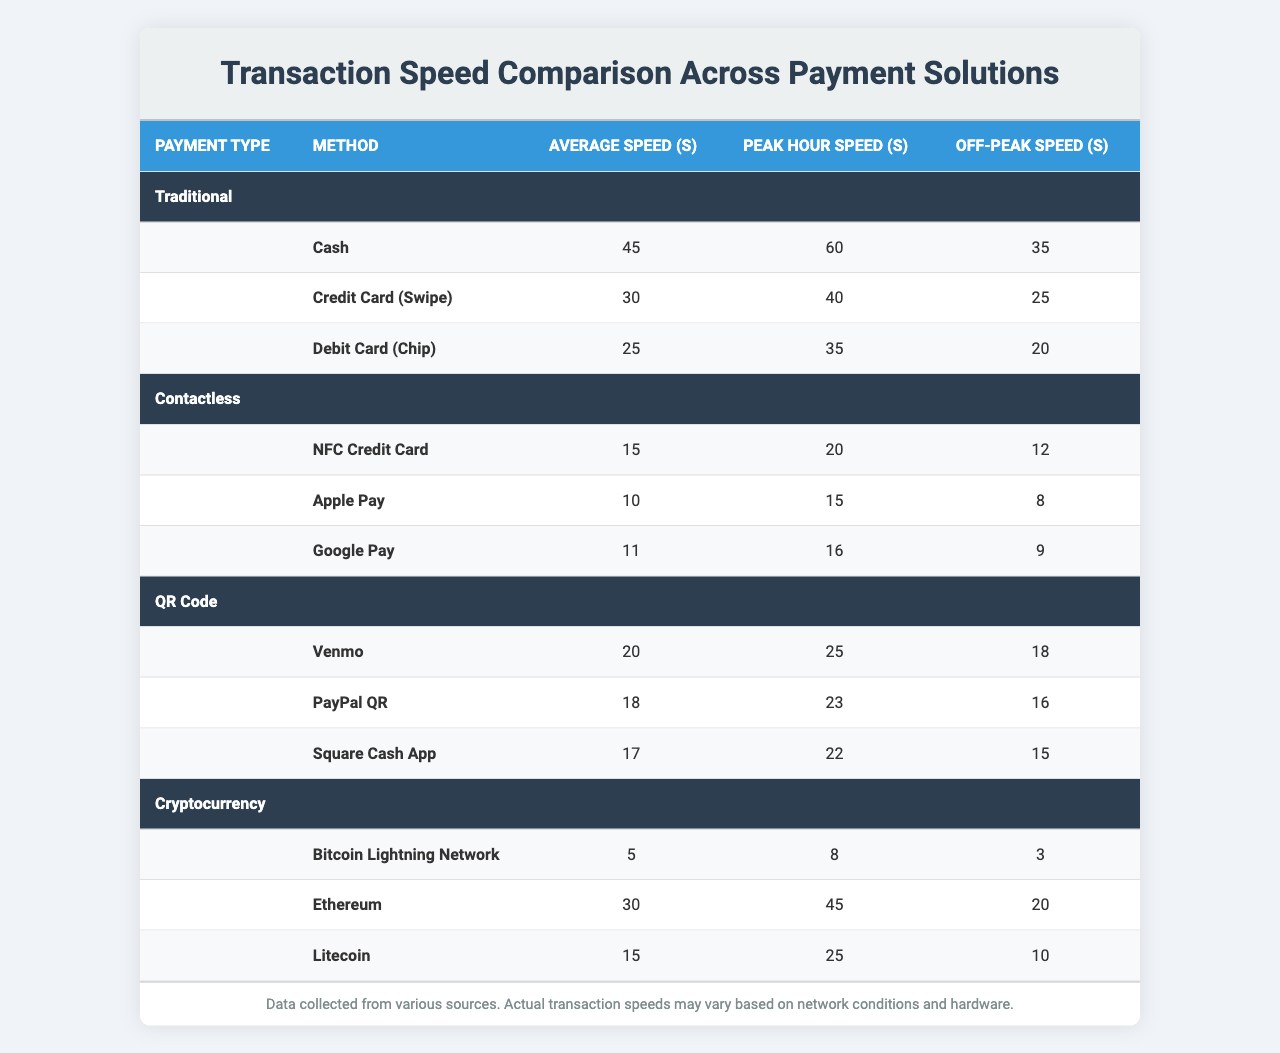What is the average transaction speed for Apple Pay? According to the table, Apple Pay has an average transaction speed of 10 seconds.
Answer: 10 seconds What is the peak hour speed of Cash transactions? The table shows that the peak hour speed for Cash transactions is 60 seconds.
Answer: 60 seconds Which payment method has the fastest average transaction speed? From the table, the Bitcoin Lightning Network has the fastest average transaction speed of 5 seconds.
Answer: Bitcoin Lightning Network How much faster is the average transaction speed of a Debit Card (Chip) compared to a Credit Card (Swipe)? The average transaction speed for Debit Card (Chip) is 25 seconds and for Credit Card (Swipe) it is 30 seconds. The difference is 30 - 25 = 5 seconds, meaning Debit Card (Chip) is 5 seconds faster.
Answer: 5 seconds What is the total average transaction speed for all Contactless payment methods? The average speeds for Contactless methods are 15 (NFC Credit Card), 10 (Apple Pay), and 11 (Google Pay). Summing these gives 15 + 10 + 11 = 36 seconds. To find the average, we divide by the number of methods (3): 36 / 3 = 12 seconds.
Answer: 12 seconds Does the average transaction speed for any Cryptocurrency method exceed 30 seconds? The Ethereum method has an average transaction speed of 30 seconds, while all other Cryptocurrency methods (Bitcoin Lightning Network and Litecoin) have speeds below that. Therefore, no method exceeds 30 seconds.
Answer: No Which payment solution has the highest peak hour speed overall? By examining the peak hour speeds, Cash has the highest with 60 seconds, compared to the peak hour speeds of other methods, such as those from Contactless (20 seconds), QR Code (25 seconds), and Cryptocurrency (45 seconds for Ethereum).
Answer: Cash What is the average off-peak speed of all QR Code payment methods? The off-peak speeds are 18 (Venmo), 16 (PayPal QR), and 15 (Square Cash App). Adding these together gives 18 + 16 + 15 = 49 seconds. Dividing by the number of methods (3) results in an average off-peak speed of 49 / 3 = 16.33 seconds, which can be rounded to 16 seconds.
Answer: 16 seconds Is the Peak Hour speed of Crypto payment solutions generally lower than that of Traditional payment solutions? The peak hour speeds for Cryptocurrencies (Bitcoin Lightning Network: 8, Ethereum: 45, Litecoin: 25) average to (8 + 45 + 25) / 3 = 26 seconds. The Traditional methods average (60 + 40 + 35) / 3 = 45 seconds, indicating that Crypto is lower.
Answer: Yes Which contactless payment method has the fastest off-peak speed? The off-peak speeds for Contactless methods are: Apple Pay (8 seconds), Google Pay (9 seconds), and NFC Credit Card (12 seconds). Apple Pay has the fastest off-peak speed at 8 seconds.
Answer: Apple Pay 